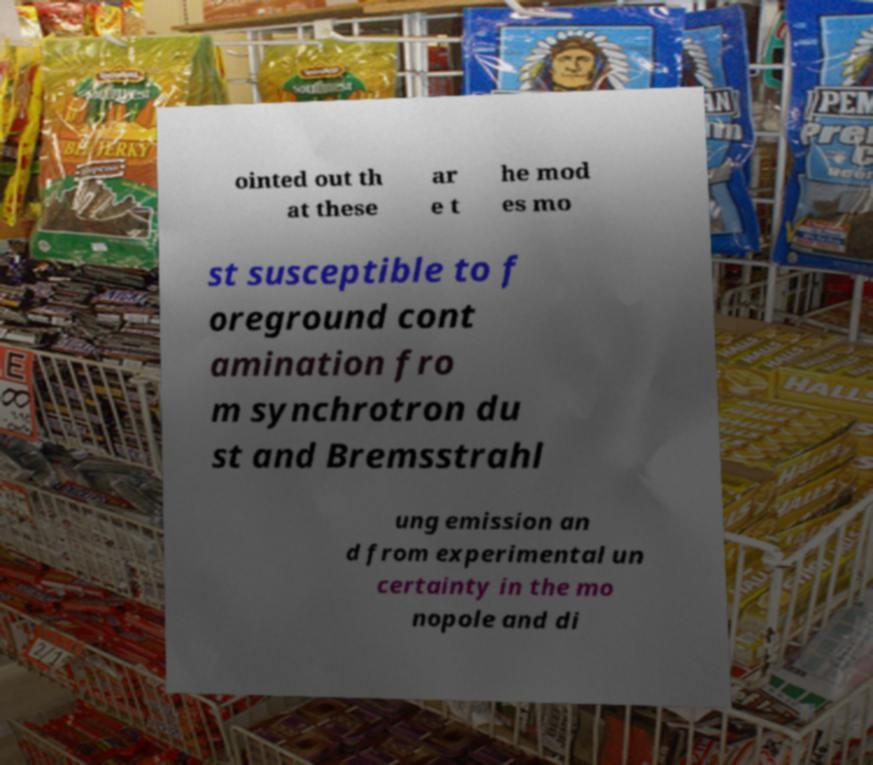Can you accurately transcribe the text from the provided image for me? ointed out th at these ar e t he mod es mo st susceptible to f oreground cont amination fro m synchrotron du st and Bremsstrahl ung emission an d from experimental un certainty in the mo nopole and di 